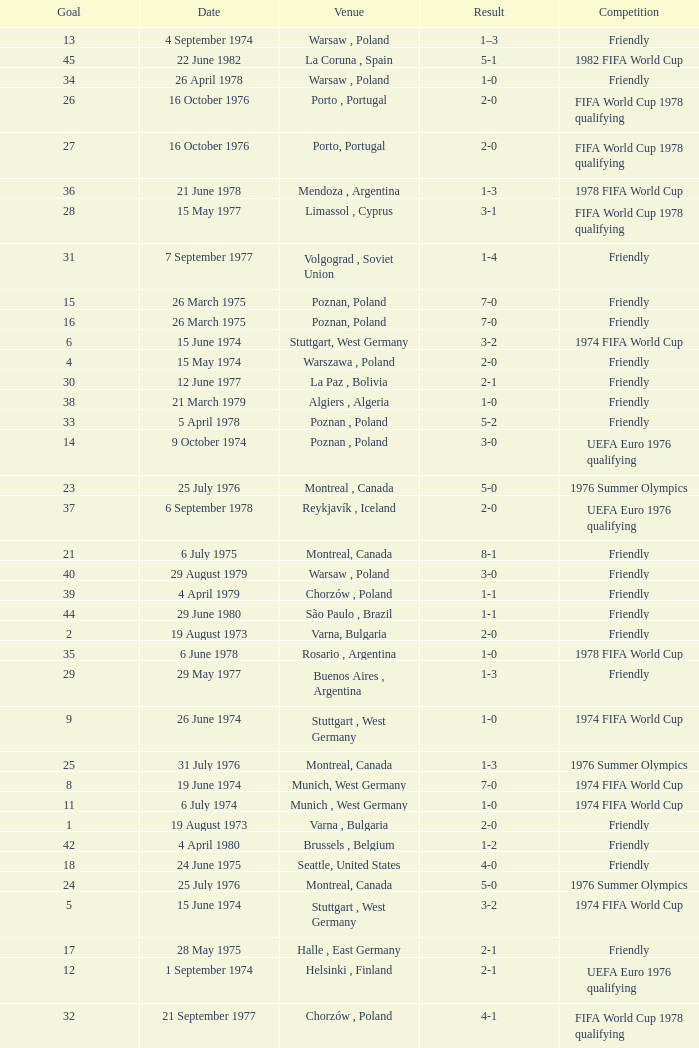What was the result of the game in Stuttgart, West Germany and a goal number of less than 9? 3-2, 3-2. 